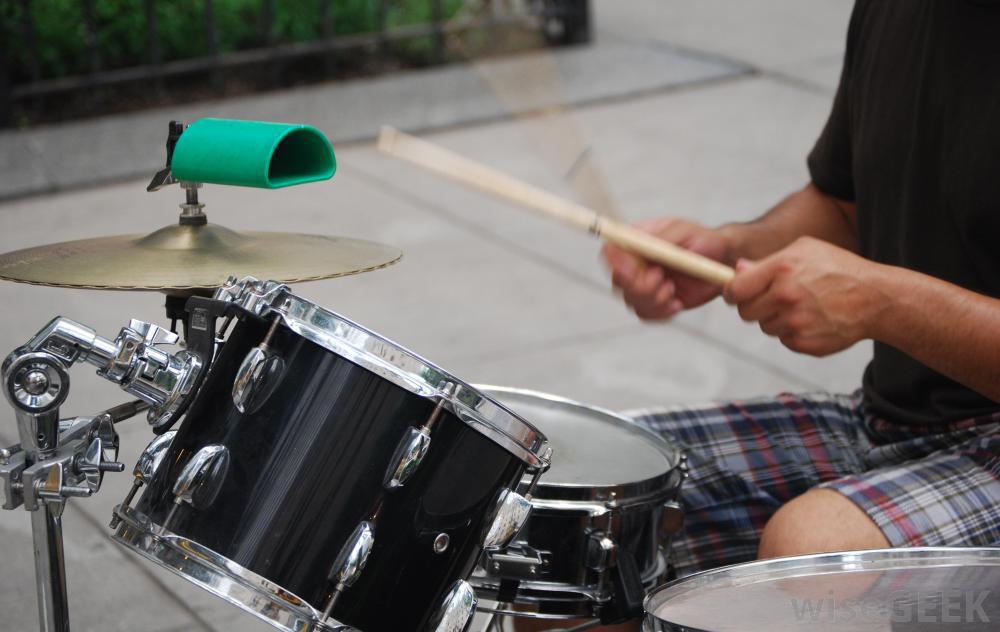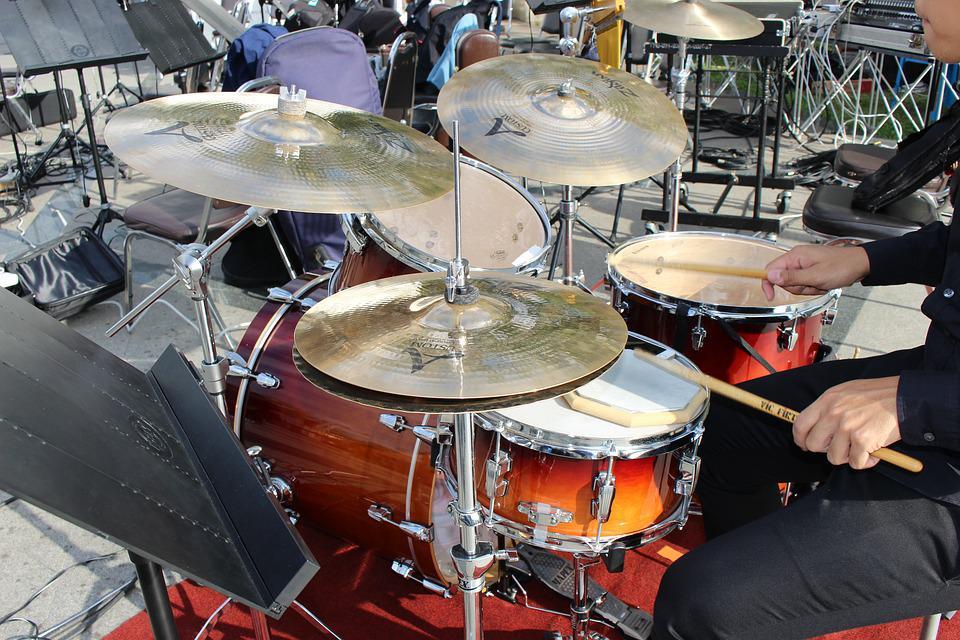The first image is the image on the left, the second image is the image on the right. Analyze the images presented: Is the assertion "At least one human is playing an instrument." valid? Answer yes or no. Yes. The first image is the image on the left, the second image is the image on the right. Evaluate the accuracy of this statement regarding the images: "Each image contains a drum kit with multiple cymbals and cylindrical drums, but no image shows someone playing the drums.". Is it true? Answer yes or no. No. 